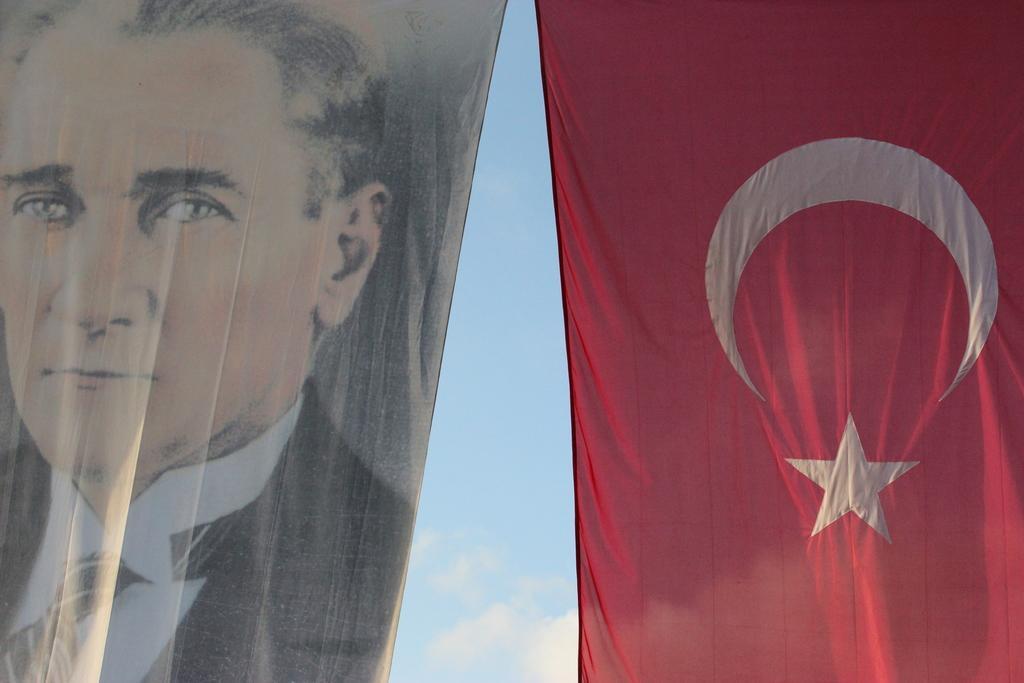How would you summarize this image in a sentence or two? This image is taken outdoors. In the middle of the image there is the sky with clouds. On the right side of the image there is a flag. The flag is red in color. There is a symbol of a half moon and a star on the flag. On the left side of the image there is a cloth and there is an image of a man on the cloth. 